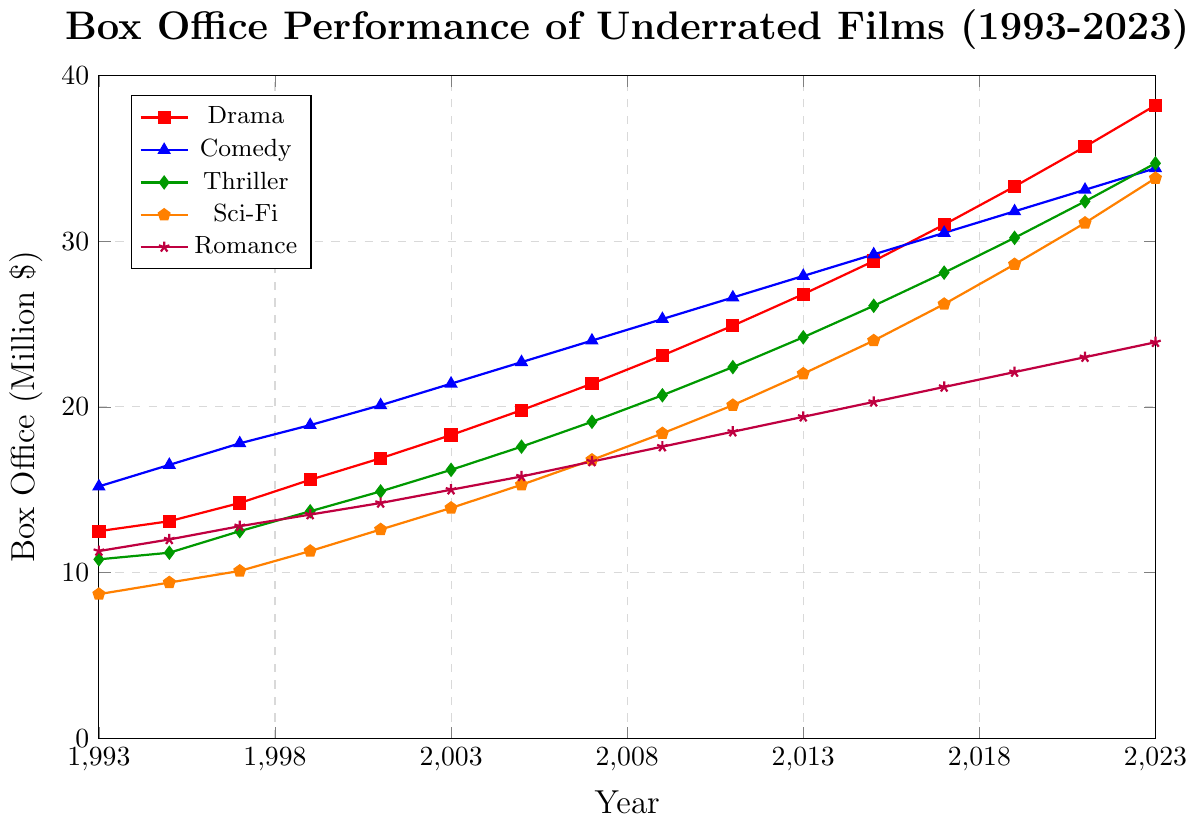Which genre had the highest box office performance in 2023? Look at the figure on the right-hand side corresponding to the year 2023 and identify the highest point among the genres. Comedy (blue plot) reaches approximately 34.4 million dollars in 2023, which is the highest.
Answer: Comedy Which genre had the lowest box office performance in 1993? Locate the year 1993 on the x-axis and identify the lowest point among the genres. Sci-Fi (orange plot) has the lowest value with approximately 8.7 million dollars.
Answer: Sci-Fi What is the difference in box office performance between Sci-Fi and Romance in 2023? In 2023, Sci-Fi is approximately at 33.8 million dollars and Romance at 23.9 million dollars. Subtract the value for Romance from Sci-Fi: 33.8 - 23.9 = 9.9.
Answer: 9.9 How has the box office performance of Thriller changed from 1993 to 2023? Locate the values for Thriller in 1993 and 2023. In 1993, it's approximately 10.8 million dollars and in 2023, it's approximately 34.7 million dollars. Subtract the value in 1993 from 2023: 34.7 - 10.8 = 23.9.
Answer: Increased by 23.9 Between which two consecutive years did Comedy see the largest increase in box office performance? Examine the increases for Comedy year by year. The largest jump is from 1997 (17.8) to 1999 (18.9), which is an increase of 1.1 million dollars. The largest increase happens between 2021 (33.1) and 2023 (34.4), i.e., an increase of 1.3 million dollars.
Answer: Between 2021 and 2023 What was the average box office performance of Drama from 1993 to 2023? Sum the values of Drama from 1993 to 2023: 12.5 + 13.1 + 14.2 + 15.6 + 16.9 + 18.3 + 19.8 + 21.4 + 23.1 + 24.9 + 26.8 + 28.8 + 31.0 + 33.3 + 35.7 + 38.2 = 374.6. There are 16 years of data. Divide the sum by 16: 374.6 / 16 = 23.4125.
Answer: 23.41 (approximately) Which genre had the most consistent increase in box office performance over the 30 years? Consistent increase implies a steady and even growth trend. Visually inspect each genre line; Sci-Fi (orange plot) shows a steady, even increase without drastic jumps or falls.
Answer: Sci-Fi Which genre outperformed Romance the most in 2023? Locate the values for each genre in 2023 and compare them with Romance (23.9). Identify the genre with the highest difference. Sci-Fi has a value of 33.8, so the difference is 33.8 - 23.9 = 9.9, which is the largest.
Answer: Sci-Fi 